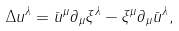<formula> <loc_0><loc_0><loc_500><loc_500>\Delta u ^ { \lambda } = \bar { u } ^ { \mu } \partial _ { \mu } \xi ^ { \lambda } - \xi ^ { \mu } \partial _ { \mu } \bar { u } ^ { \lambda } ,</formula> 